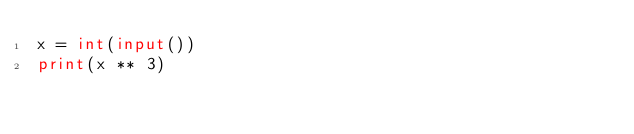Convert code to text. <code><loc_0><loc_0><loc_500><loc_500><_Python_>x = int(input())
print(x ** 3)
</code> 